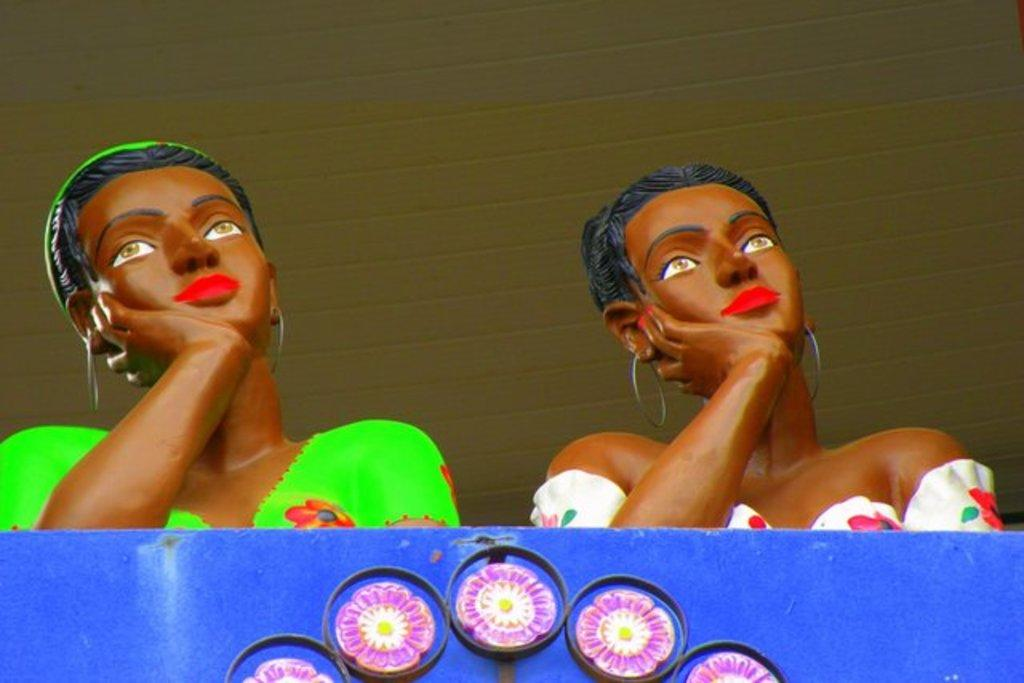How many statues are present in the image? There are two statues in the image. Can you describe the color or appearance of any objects in the image? Yes, there is a blue object in the image. What type of dress is the cook wearing in the image? There is no cook or dress present in the image; it features two statues and a blue object. 